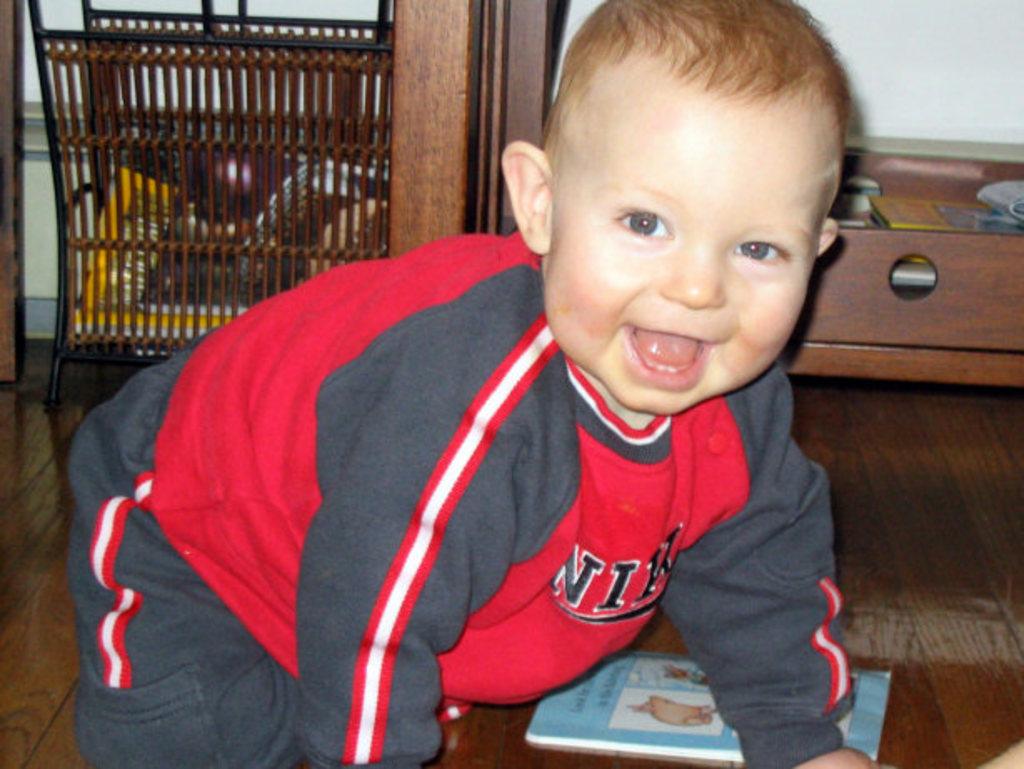Is the child wearing an expensive nike shirt?
Ensure brevity in your answer.  Answering does not require reading text in the image. 